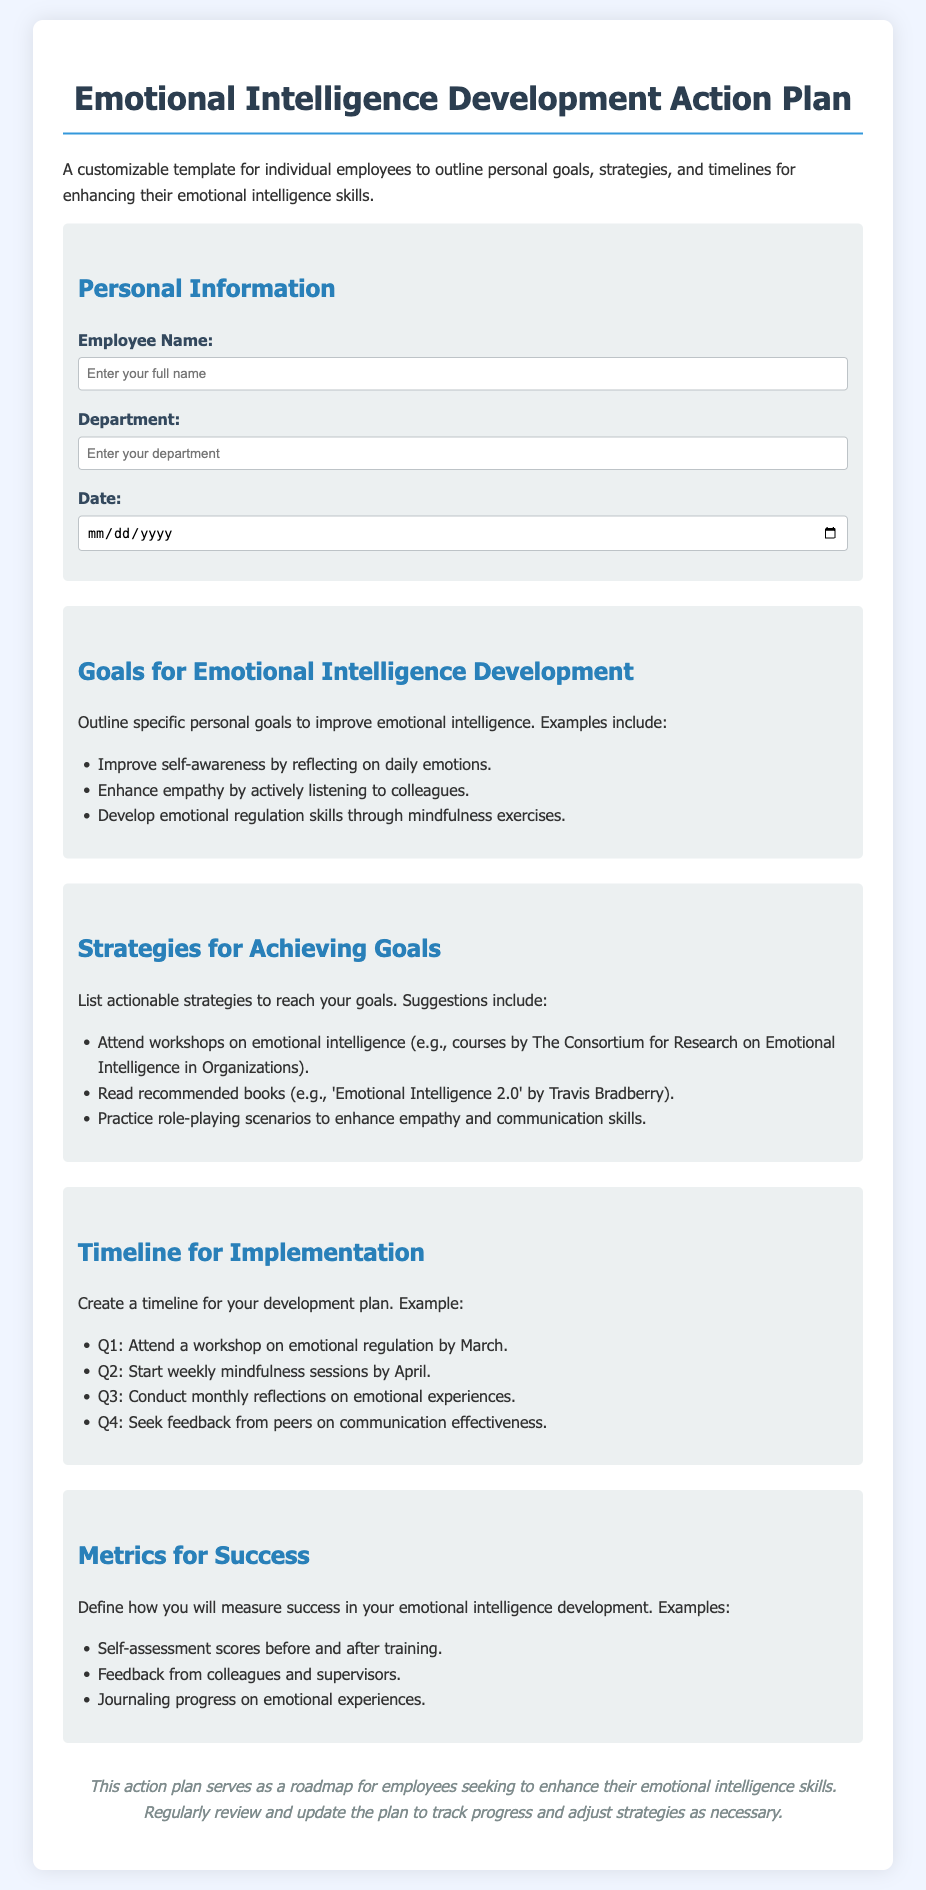what is the title of the document? The title appears at the top of the document and is emphasized in larger font.
Answer: Emotional Intelligence Development Action Plan who is the target audience for this document? The introduction clearly states that the document is a customizable template for individual employees.
Answer: Employees what is one example of a goal for emotional intelligence development? The document lists examples in the section for goals; one of them highlights a specific competency.
Answer: Improve self-awareness by reflecting on daily emotions which quarter should mindfulness sessions start? The timeline section specifies when to begin certain practices, including mindfulness.
Answer: Q2 name one strategy suggested for achieving emotional intelligence goals. The strategies section includes a list, one of which is a specific activity related to learning.
Answer: Attend workshops on emotional intelligence how can success be measured according to the document? The metrics for success section outlines various ways to evaluate progress, including specific assessment types.
Answer: Self-assessment scores before and after training what is a recommended book to read for emotional intelligence improvement? The document provides a specific book title as part of its strategies list aimed at enhancing emotional intelligence.
Answer: 'Emotional Intelligence 2.0' when should feedback from peers be sought? The timeline section indicates when to request peer feedback in the development process.
Answer: Q4 